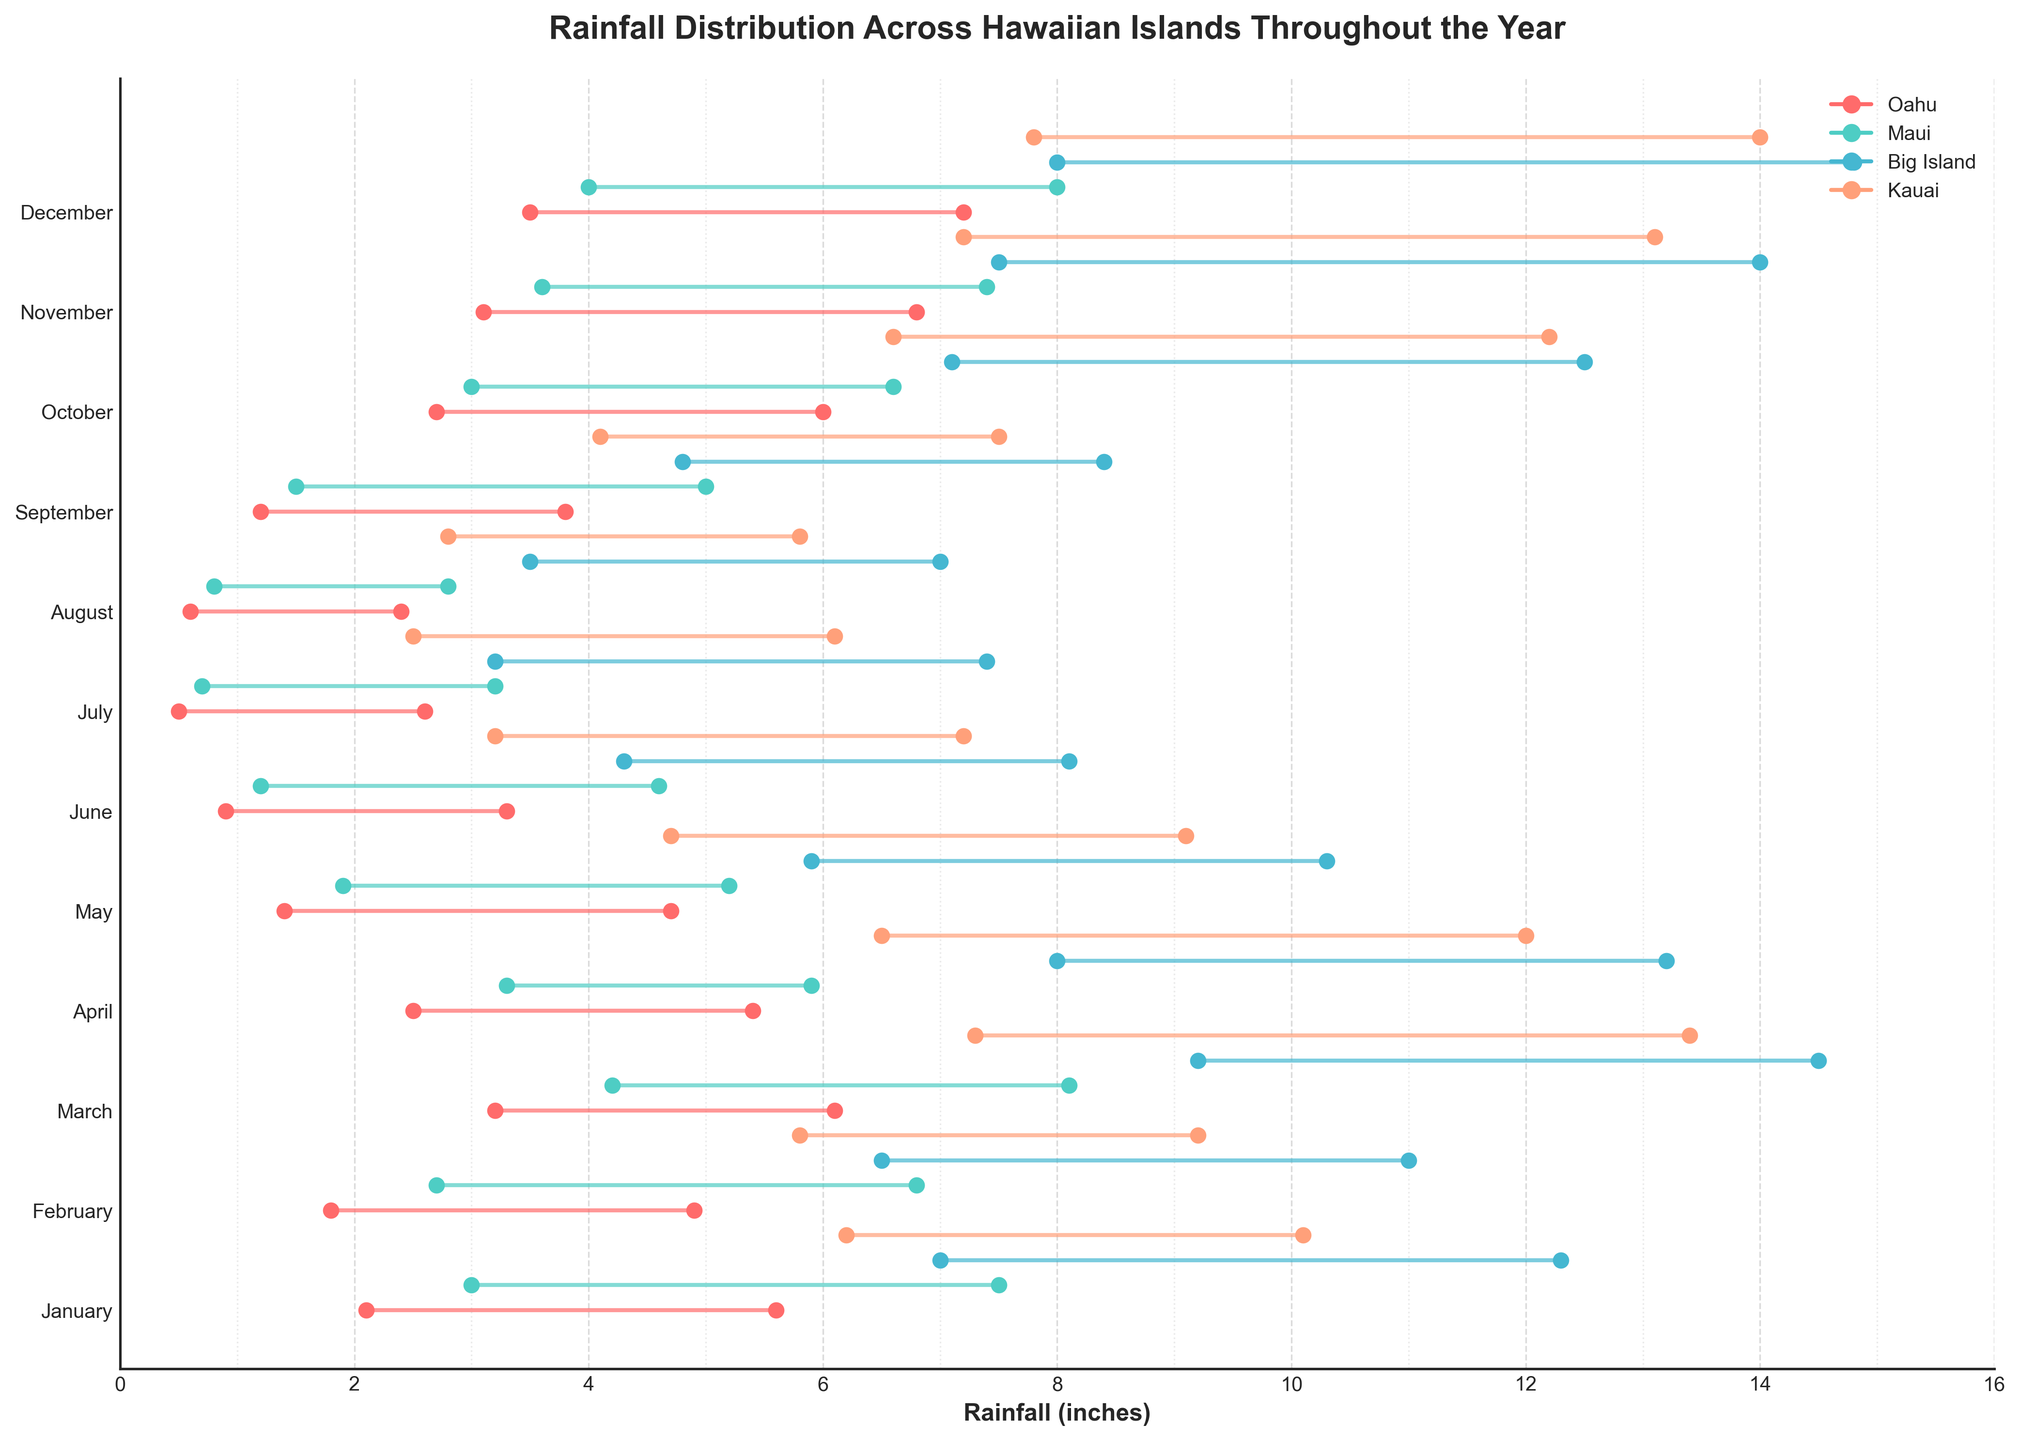What's the maximum rainfall recorded in Honolulu during the year? The maximum rainfall in Honolulu was recorded in December. By checking the plot, the highest value in December is 7.2 inches.
Answer: 7.2 inches Which island has the highest minimum rainfall recorded in any month? Examine the minimum rainfall values for each island across all months. Hilo on the Big Island has the highest minimum rainfall in March with 9.2 inches.
Answer: Hilo During which month does Hilo on the Big Island experience the lowest minimum rainfall? Look at the plotted minimum rainfall values for Hilo across all months. The lowest minimum rainfall for Hilo is in July, with 3.2 inches.
Answer: July Compare the range of rainfall in January between Honolulu and Princeville. Which location has a wider range? Calculate the range by subtracting the minimum rainfall from the maximum rainfall for both locations in January. For Honolulu, the range is 5.6 - 2.1 = 3.5 inches, and for Princeville, it is 10.1 - 6.2 = 3.9 inches. Princeville has a wider range.
Answer: Princeville What month does Kahului have the closest maximum rainfall to 8 inches? Observe the maximum rainfall values for Kahului across all months. In March, the maximum rainfall is 8.1 inches, which is closest to 8 inches.
Answer: March How does the average minimum rainfall in July compare between all four islands? Calculate the average minimum rainfall in July for each island. Honolulu: 0.5 inches, Kahului: 0.7 inches, Hilo: 3.2 inches, Princeville: 2.5 inches. The average minimum rainfall for the four islands in July is \( \frac{0.5 + 0.7 + 3.2 + 2.5}{4} = 1.725 \) inches.
Answer: 1.725 inches Which month has the greatest difference between minimum and maximum rainfall for Kahului? Calculate the difference between the maximum and minimum rainfall for each month in Kahului and identify the month with the greatest difference. March has the maximum difference of 8.1 - 4.2 = 3.9 inches.
Answer: March Is there any month where all islands have rainfall ranges above 3 inches? Check each month to see if all islands' ranges (max - min) exceed 3 inches. Only in March: Honolulu (6.1-3.2=2.9), Kahului (8.1-4.2=3.9), Hilo (14.5-9.2=5.3), and Princeville (13.4-7.3=6.1). March doesn't meet criteria; thus, no month satisfies this condition.
Answer: No 